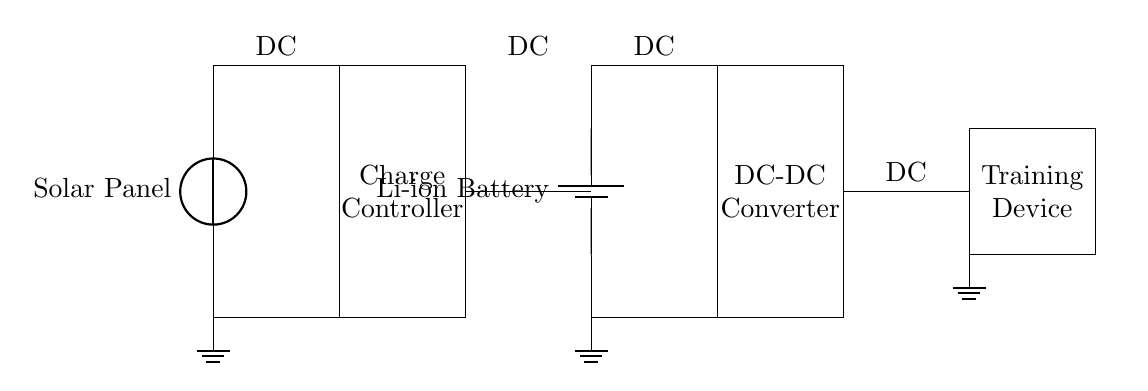What is the primary source of power in this circuit? The primary source of power is the solar panel, which converts sunlight into electrical energy. This is indicated at the leftmost part of the diagram.
Answer: Solar Panel What component regulates the charge to the battery? The charge controller is the component responsible for regulating the charge going to the battery. It prevents overcharging and ensures the battery is charged efficiently. This is shown as a rectangle labeled "Charge Controller" connected between the solar panel and the battery.
Answer: Charge Controller Which type of battery is used in this circuit? The battery used in this circuit is a lithium-ion battery, which is commonly used due to its efficiency and energy density. The diagram clearly labels the battery type in the middle right section of the circuit.
Answer: Li-ion Battery How does the solar panel connect to the system? The solar panel connects to the charge controller through two wires, one for positive and another for negative, indicating a direct connection for the DC power supply. This can be traced from the solar panel to the charge controller in the diagram.
Answer: Directly What type of conversion does the DC-DC converter provide? The DC-DC converter provides voltage regulation, allowing the output voltage to match the required specifications of the training device. This is done to ensure compatibility with the device's power requirements.
Answer: Voltage Regulation 